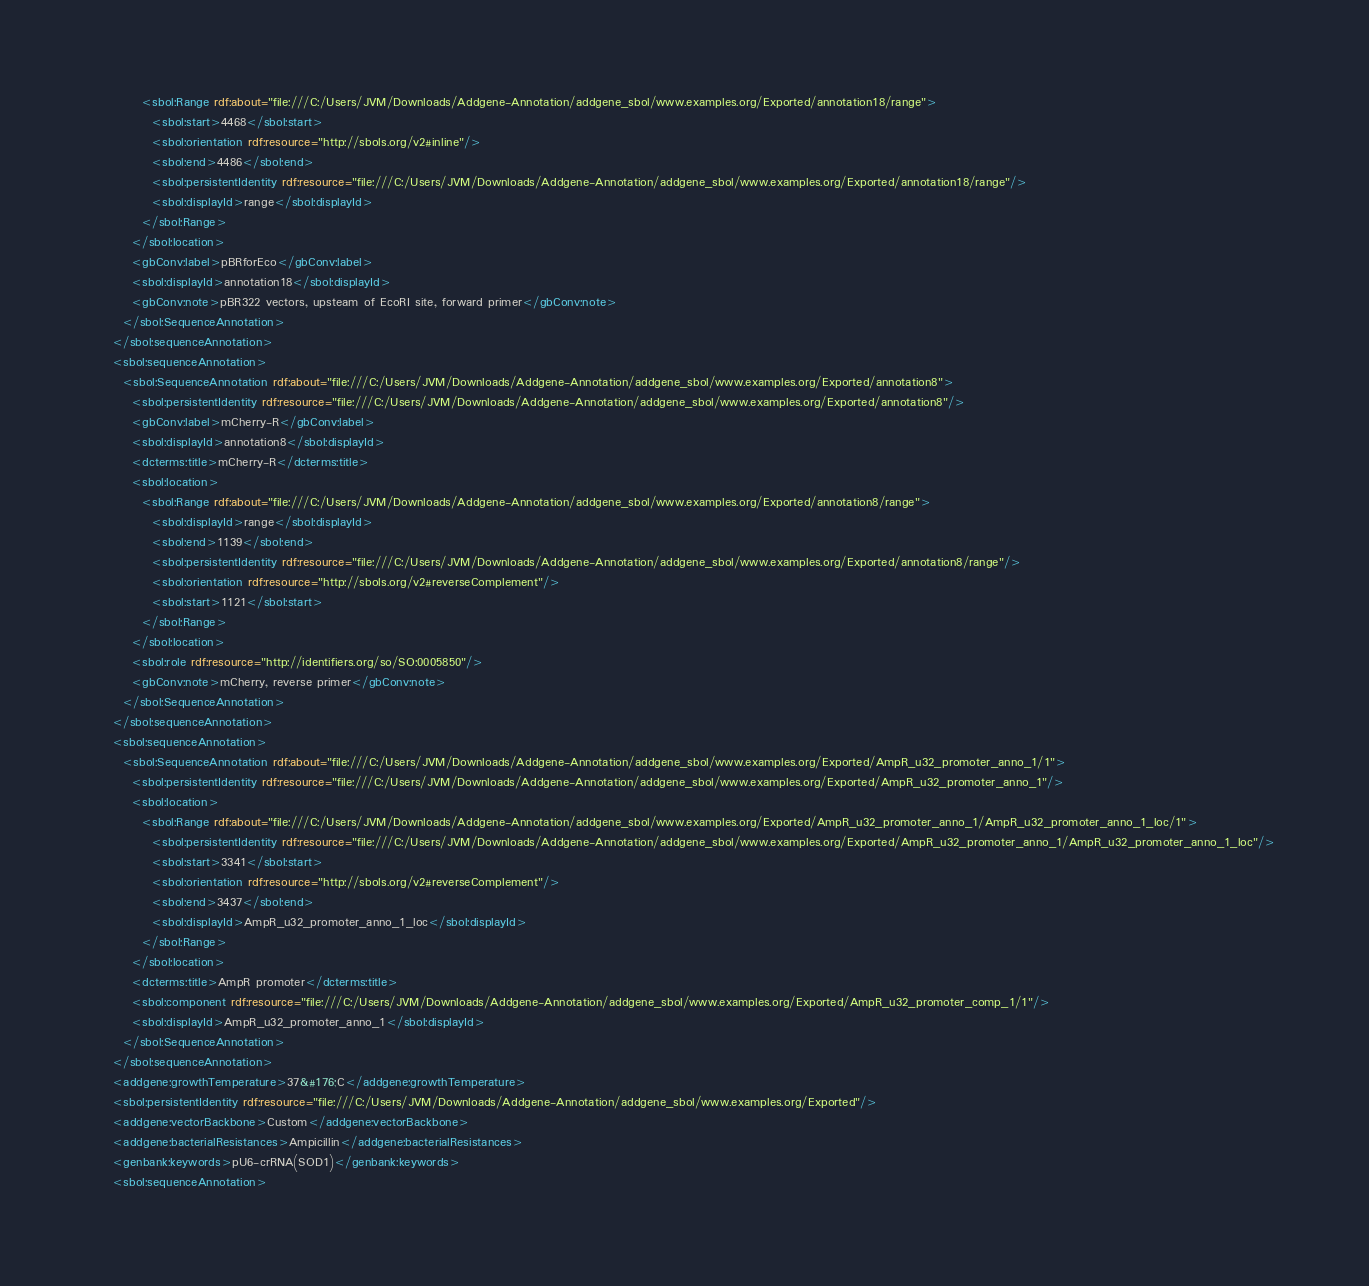<code> <loc_0><loc_0><loc_500><loc_500><_XML_>          <sbol:Range rdf:about="file:///C:/Users/JVM/Downloads/Addgene-Annotation/addgene_sbol/www.examples.org/Exported/annotation18/range">
            <sbol:start>4468</sbol:start>
            <sbol:orientation rdf:resource="http://sbols.org/v2#inline"/>
            <sbol:end>4486</sbol:end>
            <sbol:persistentIdentity rdf:resource="file:///C:/Users/JVM/Downloads/Addgene-Annotation/addgene_sbol/www.examples.org/Exported/annotation18/range"/>
            <sbol:displayId>range</sbol:displayId>
          </sbol:Range>
        </sbol:location>
        <gbConv:label>pBRforEco</gbConv:label>
        <sbol:displayId>annotation18</sbol:displayId>
        <gbConv:note>pBR322 vectors, upsteam of EcoRI site, forward primer</gbConv:note>
      </sbol:SequenceAnnotation>
    </sbol:sequenceAnnotation>
    <sbol:sequenceAnnotation>
      <sbol:SequenceAnnotation rdf:about="file:///C:/Users/JVM/Downloads/Addgene-Annotation/addgene_sbol/www.examples.org/Exported/annotation8">
        <sbol:persistentIdentity rdf:resource="file:///C:/Users/JVM/Downloads/Addgene-Annotation/addgene_sbol/www.examples.org/Exported/annotation8"/>
        <gbConv:label>mCherry-R</gbConv:label>
        <sbol:displayId>annotation8</sbol:displayId>
        <dcterms:title>mCherry-R</dcterms:title>
        <sbol:location>
          <sbol:Range rdf:about="file:///C:/Users/JVM/Downloads/Addgene-Annotation/addgene_sbol/www.examples.org/Exported/annotation8/range">
            <sbol:displayId>range</sbol:displayId>
            <sbol:end>1139</sbol:end>
            <sbol:persistentIdentity rdf:resource="file:///C:/Users/JVM/Downloads/Addgene-Annotation/addgene_sbol/www.examples.org/Exported/annotation8/range"/>
            <sbol:orientation rdf:resource="http://sbols.org/v2#reverseComplement"/>
            <sbol:start>1121</sbol:start>
          </sbol:Range>
        </sbol:location>
        <sbol:role rdf:resource="http://identifiers.org/so/SO:0005850"/>
        <gbConv:note>mCherry, reverse primer</gbConv:note>
      </sbol:SequenceAnnotation>
    </sbol:sequenceAnnotation>
    <sbol:sequenceAnnotation>
      <sbol:SequenceAnnotation rdf:about="file:///C:/Users/JVM/Downloads/Addgene-Annotation/addgene_sbol/www.examples.org/Exported/AmpR_u32_promoter_anno_1/1">
        <sbol:persistentIdentity rdf:resource="file:///C:/Users/JVM/Downloads/Addgene-Annotation/addgene_sbol/www.examples.org/Exported/AmpR_u32_promoter_anno_1"/>
        <sbol:location>
          <sbol:Range rdf:about="file:///C:/Users/JVM/Downloads/Addgene-Annotation/addgene_sbol/www.examples.org/Exported/AmpR_u32_promoter_anno_1/AmpR_u32_promoter_anno_1_loc/1">
            <sbol:persistentIdentity rdf:resource="file:///C:/Users/JVM/Downloads/Addgene-Annotation/addgene_sbol/www.examples.org/Exported/AmpR_u32_promoter_anno_1/AmpR_u32_promoter_anno_1_loc"/>
            <sbol:start>3341</sbol:start>
            <sbol:orientation rdf:resource="http://sbols.org/v2#reverseComplement"/>
            <sbol:end>3437</sbol:end>
            <sbol:displayId>AmpR_u32_promoter_anno_1_loc</sbol:displayId>
          </sbol:Range>
        </sbol:location>
        <dcterms:title>AmpR promoter</dcterms:title>
        <sbol:component rdf:resource="file:///C:/Users/JVM/Downloads/Addgene-Annotation/addgene_sbol/www.examples.org/Exported/AmpR_u32_promoter_comp_1/1"/>
        <sbol:displayId>AmpR_u32_promoter_anno_1</sbol:displayId>
      </sbol:SequenceAnnotation>
    </sbol:sequenceAnnotation>
    <addgene:growthTemperature>37&#176;C</addgene:growthTemperature>
    <sbol:persistentIdentity rdf:resource="file:///C:/Users/JVM/Downloads/Addgene-Annotation/addgene_sbol/www.examples.org/Exported"/>
    <addgene:vectorBackbone>Custom</addgene:vectorBackbone>
    <addgene:bacterialResistances>Ampicillin</addgene:bacterialResistances>
    <genbank:keywords>pU6-crRNA(SOD1)</genbank:keywords>
    <sbol:sequenceAnnotation></code> 